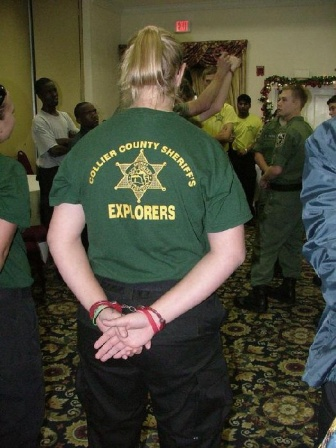Can you provide more details about the people and their activities in this image? Certainly! At the center of attention, a person stands with their back to the camera, wearing the signature green t-shirt of the Collier County Sheriff's Explorers. This group appears to be actively participating in some form of structured event or ceremony. To the left, a small crowd watches attentively, suggesting that something important or official might be taking place. At the forefront, a man wearing a gray uniform seems to be addressing the group, possibly giving a speech or instructions. The room is filled with energy and purpose, with young explorers interacting with uniformed officers, indicating this could be an educational or community-building event. 